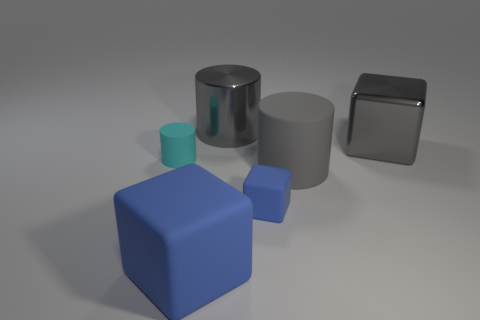Subtract all small cyan matte cylinders. How many cylinders are left? 2 Subtract 2 cubes. How many cubes are left? 1 Subtract all cyan cylinders. How many cylinders are left? 2 Add 3 cyan metal cubes. How many objects exist? 9 Subtract all yellow cylinders. How many brown cubes are left? 0 Subtract all cyan blocks. Subtract all brown balls. How many blocks are left? 3 Add 6 cylinders. How many cylinders are left? 9 Add 6 large red metal cubes. How many large red metal cubes exist? 6 Subtract 0 purple blocks. How many objects are left? 6 Subtract all metal things. Subtract all big blue cubes. How many objects are left? 3 